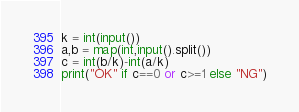<code> <loc_0><loc_0><loc_500><loc_500><_Python_>k = int(input())
a,b = map(int,input().split())
c = int(b/k)-int(a/k)
print("OK" if c==0 or c>=1 else "NG")</code> 